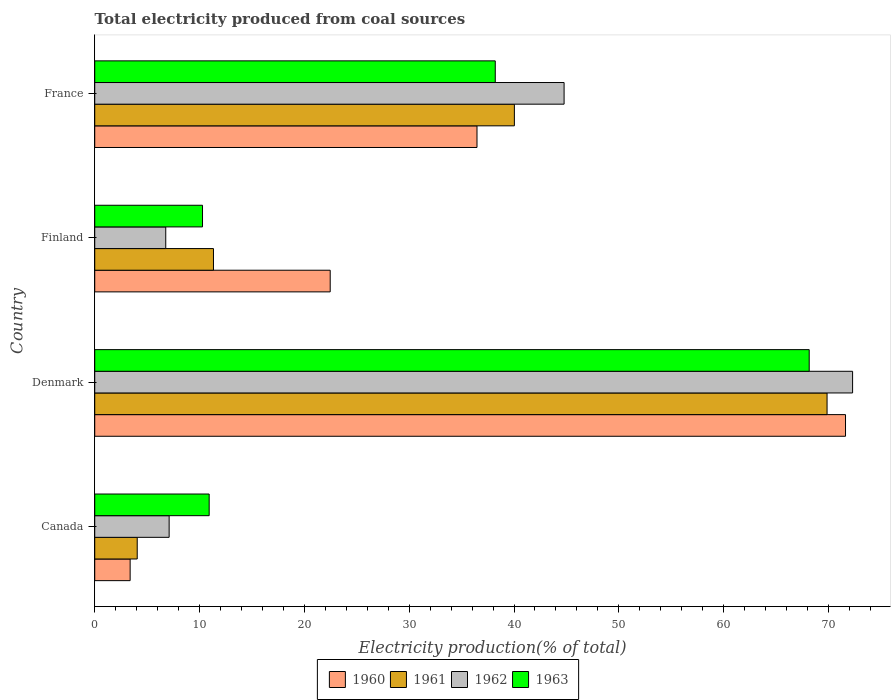How many groups of bars are there?
Provide a short and direct response. 4. Are the number of bars per tick equal to the number of legend labels?
Your answer should be compact. Yes. Are the number of bars on each tick of the Y-axis equal?
Ensure brevity in your answer.  Yes. How many bars are there on the 1st tick from the top?
Provide a short and direct response. 4. What is the total electricity produced in 1963 in Finland?
Your response must be concise. 10.28. Across all countries, what is the maximum total electricity produced in 1963?
Make the answer very short. 68.16. Across all countries, what is the minimum total electricity produced in 1962?
Keep it short and to the point. 6.78. What is the total total electricity produced in 1961 in the graph?
Provide a short and direct response. 125.28. What is the difference between the total electricity produced in 1960 in Denmark and that in France?
Offer a very short reply. 35.16. What is the difference between the total electricity produced in 1962 in Denmark and the total electricity produced in 1963 in Finland?
Offer a very short reply. 62.02. What is the average total electricity produced in 1960 per country?
Provide a short and direct response. 33.48. What is the difference between the total electricity produced in 1962 and total electricity produced in 1960 in Finland?
Your response must be concise. -15.69. In how many countries, is the total electricity produced in 1960 greater than 36 %?
Offer a very short reply. 2. What is the ratio of the total electricity produced in 1963 in Denmark to that in France?
Provide a succinct answer. 1.78. Is the total electricity produced in 1962 in Canada less than that in Denmark?
Your answer should be compact. Yes. Is the difference between the total electricity produced in 1962 in Finland and France greater than the difference between the total electricity produced in 1960 in Finland and France?
Make the answer very short. No. What is the difference between the highest and the second highest total electricity produced in 1961?
Offer a terse response. 29.83. What is the difference between the highest and the lowest total electricity produced in 1961?
Provide a succinct answer. 65.81. Is the sum of the total electricity produced in 1960 in Denmark and France greater than the maximum total electricity produced in 1962 across all countries?
Provide a short and direct response. Yes. Is it the case that in every country, the sum of the total electricity produced in 1960 and total electricity produced in 1962 is greater than the sum of total electricity produced in 1963 and total electricity produced in 1961?
Your answer should be very brief. No. What does the 1st bar from the top in France represents?
Keep it short and to the point. 1963. What does the 3rd bar from the bottom in Finland represents?
Your response must be concise. 1962. Is it the case that in every country, the sum of the total electricity produced in 1961 and total electricity produced in 1960 is greater than the total electricity produced in 1962?
Provide a short and direct response. Yes. Are all the bars in the graph horizontal?
Make the answer very short. Yes. What is the difference between two consecutive major ticks on the X-axis?
Your answer should be compact. 10. Are the values on the major ticks of X-axis written in scientific E-notation?
Keep it short and to the point. No. Does the graph contain any zero values?
Your answer should be compact. No. How many legend labels are there?
Keep it short and to the point. 4. What is the title of the graph?
Offer a terse response. Total electricity produced from coal sources. What is the label or title of the X-axis?
Make the answer very short. Electricity production(% of total). What is the Electricity production(% of total) of 1960 in Canada?
Your response must be concise. 3.38. What is the Electricity production(% of total) in 1961 in Canada?
Provide a succinct answer. 4.05. What is the Electricity production(% of total) of 1962 in Canada?
Offer a very short reply. 7.1. What is the Electricity production(% of total) of 1963 in Canada?
Ensure brevity in your answer.  10.92. What is the Electricity production(% of total) of 1960 in Denmark?
Offer a very short reply. 71.62. What is the Electricity production(% of total) of 1961 in Denmark?
Provide a succinct answer. 69.86. What is the Electricity production(% of total) in 1962 in Denmark?
Your answer should be very brief. 72.3. What is the Electricity production(% of total) of 1963 in Denmark?
Your answer should be compact. 68.16. What is the Electricity production(% of total) of 1960 in Finland?
Your response must be concise. 22.46. What is the Electricity production(% of total) of 1961 in Finland?
Ensure brevity in your answer.  11.33. What is the Electricity production(% of total) in 1962 in Finland?
Ensure brevity in your answer.  6.78. What is the Electricity production(% of total) of 1963 in Finland?
Provide a short and direct response. 10.28. What is the Electricity production(% of total) of 1960 in France?
Provide a succinct answer. 36.47. What is the Electricity production(% of total) in 1961 in France?
Your response must be concise. 40.03. What is the Electricity production(% of total) in 1962 in France?
Ensure brevity in your answer.  44.78. What is the Electricity production(% of total) in 1963 in France?
Give a very brief answer. 38.21. Across all countries, what is the maximum Electricity production(% of total) in 1960?
Your answer should be compact. 71.62. Across all countries, what is the maximum Electricity production(% of total) in 1961?
Keep it short and to the point. 69.86. Across all countries, what is the maximum Electricity production(% of total) of 1962?
Keep it short and to the point. 72.3. Across all countries, what is the maximum Electricity production(% of total) in 1963?
Provide a short and direct response. 68.16. Across all countries, what is the minimum Electricity production(% of total) in 1960?
Your answer should be very brief. 3.38. Across all countries, what is the minimum Electricity production(% of total) in 1961?
Offer a terse response. 4.05. Across all countries, what is the minimum Electricity production(% of total) of 1962?
Give a very brief answer. 6.78. Across all countries, what is the minimum Electricity production(% of total) of 1963?
Make the answer very short. 10.28. What is the total Electricity production(% of total) in 1960 in the graph?
Make the answer very short. 133.93. What is the total Electricity production(% of total) in 1961 in the graph?
Offer a very short reply. 125.28. What is the total Electricity production(% of total) of 1962 in the graph?
Make the answer very short. 130.95. What is the total Electricity production(% of total) of 1963 in the graph?
Give a very brief answer. 127.57. What is the difference between the Electricity production(% of total) in 1960 in Canada and that in Denmark?
Your response must be concise. -68.25. What is the difference between the Electricity production(% of total) of 1961 in Canada and that in Denmark?
Provide a succinct answer. -65.81. What is the difference between the Electricity production(% of total) of 1962 in Canada and that in Denmark?
Ensure brevity in your answer.  -65.2. What is the difference between the Electricity production(% of total) in 1963 in Canada and that in Denmark?
Ensure brevity in your answer.  -57.24. What is the difference between the Electricity production(% of total) of 1960 in Canada and that in Finland?
Offer a terse response. -19.09. What is the difference between the Electricity production(% of total) in 1961 in Canada and that in Finland?
Provide a succinct answer. -7.27. What is the difference between the Electricity production(% of total) in 1962 in Canada and that in Finland?
Offer a very short reply. 0.32. What is the difference between the Electricity production(% of total) of 1963 in Canada and that in Finland?
Make the answer very short. 0.63. What is the difference between the Electricity production(% of total) of 1960 in Canada and that in France?
Ensure brevity in your answer.  -33.09. What is the difference between the Electricity production(% of total) in 1961 in Canada and that in France?
Provide a short and direct response. -35.98. What is the difference between the Electricity production(% of total) in 1962 in Canada and that in France?
Make the answer very short. -37.68. What is the difference between the Electricity production(% of total) in 1963 in Canada and that in France?
Your answer should be very brief. -27.29. What is the difference between the Electricity production(% of total) of 1960 in Denmark and that in Finland?
Your response must be concise. 49.16. What is the difference between the Electricity production(% of total) of 1961 in Denmark and that in Finland?
Your answer should be very brief. 58.54. What is the difference between the Electricity production(% of total) in 1962 in Denmark and that in Finland?
Keep it short and to the point. 65.53. What is the difference between the Electricity production(% of total) in 1963 in Denmark and that in Finland?
Provide a short and direct response. 57.88. What is the difference between the Electricity production(% of total) of 1960 in Denmark and that in France?
Give a very brief answer. 35.16. What is the difference between the Electricity production(% of total) of 1961 in Denmark and that in France?
Make the answer very short. 29.83. What is the difference between the Electricity production(% of total) of 1962 in Denmark and that in France?
Ensure brevity in your answer.  27.52. What is the difference between the Electricity production(% of total) in 1963 in Denmark and that in France?
Your response must be concise. 29.95. What is the difference between the Electricity production(% of total) of 1960 in Finland and that in France?
Give a very brief answer. -14.01. What is the difference between the Electricity production(% of total) in 1961 in Finland and that in France?
Your answer should be compact. -28.71. What is the difference between the Electricity production(% of total) of 1962 in Finland and that in France?
Your answer should be compact. -38. What is the difference between the Electricity production(% of total) of 1963 in Finland and that in France?
Keep it short and to the point. -27.93. What is the difference between the Electricity production(% of total) of 1960 in Canada and the Electricity production(% of total) of 1961 in Denmark?
Make the answer very short. -66.49. What is the difference between the Electricity production(% of total) of 1960 in Canada and the Electricity production(% of total) of 1962 in Denmark?
Keep it short and to the point. -68.92. What is the difference between the Electricity production(% of total) of 1960 in Canada and the Electricity production(% of total) of 1963 in Denmark?
Your answer should be compact. -64.78. What is the difference between the Electricity production(% of total) in 1961 in Canada and the Electricity production(% of total) in 1962 in Denmark?
Ensure brevity in your answer.  -68.25. What is the difference between the Electricity production(% of total) in 1961 in Canada and the Electricity production(% of total) in 1963 in Denmark?
Your response must be concise. -64.11. What is the difference between the Electricity production(% of total) in 1962 in Canada and the Electricity production(% of total) in 1963 in Denmark?
Your answer should be very brief. -61.06. What is the difference between the Electricity production(% of total) in 1960 in Canada and the Electricity production(% of total) in 1961 in Finland?
Offer a terse response. -7.95. What is the difference between the Electricity production(% of total) of 1960 in Canada and the Electricity production(% of total) of 1962 in Finland?
Your answer should be very brief. -3.4. What is the difference between the Electricity production(% of total) in 1960 in Canada and the Electricity production(% of total) in 1963 in Finland?
Offer a very short reply. -6.91. What is the difference between the Electricity production(% of total) of 1961 in Canada and the Electricity production(% of total) of 1962 in Finland?
Offer a terse response. -2.72. What is the difference between the Electricity production(% of total) in 1961 in Canada and the Electricity production(% of total) in 1963 in Finland?
Offer a terse response. -6.23. What is the difference between the Electricity production(% of total) of 1962 in Canada and the Electricity production(% of total) of 1963 in Finland?
Make the answer very short. -3.18. What is the difference between the Electricity production(% of total) in 1960 in Canada and the Electricity production(% of total) in 1961 in France?
Provide a short and direct response. -36.66. What is the difference between the Electricity production(% of total) in 1960 in Canada and the Electricity production(% of total) in 1962 in France?
Give a very brief answer. -41.4. What is the difference between the Electricity production(% of total) of 1960 in Canada and the Electricity production(% of total) of 1963 in France?
Your response must be concise. -34.83. What is the difference between the Electricity production(% of total) of 1961 in Canada and the Electricity production(% of total) of 1962 in France?
Make the answer very short. -40.72. What is the difference between the Electricity production(% of total) of 1961 in Canada and the Electricity production(% of total) of 1963 in France?
Offer a terse response. -34.16. What is the difference between the Electricity production(% of total) of 1962 in Canada and the Electricity production(% of total) of 1963 in France?
Offer a very short reply. -31.11. What is the difference between the Electricity production(% of total) in 1960 in Denmark and the Electricity production(% of total) in 1961 in Finland?
Your response must be concise. 60.3. What is the difference between the Electricity production(% of total) of 1960 in Denmark and the Electricity production(% of total) of 1962 in Finland?
Your response must be concise. 64.85. What is the difference between the Electricity production(% of total) of 1960 in Denmark and the Electricity production(% of total) of 1963 in Finland?
Ensure brevity in your answer.  61.34. What is the difference between the Electricity production(% of total) of 1961 in Denmark and the Electricity production(% of total) of 1962 in Finland?
Offer a terse response. 63.09. What is the difference between the Electricity production(% of total) in 1961 in Denmark and the Electricity production(% of total) in 1963 in Finland?
Give a very brief answer. 59.58. What is the difference between the Electricity production(% of total) of 1962 in Denmark and the Electricity production(% of total) of 1963 in Finland?
Give a very brief answer. 62.02. What is the difference between the Electricity production(% of total) in 1960 in Denmark and the Electricity production(% of total) in 1961 in France?
Your answer should be very brief. 31.59. What is the difference between the Electricity production(% of total) in 1960 in Denmark and the Electricity production(% of total) in 1962 in France?
Ensure brevity in your answer.  26.85. What is the difference between the Electricity production(% of total) in 1960 in Denmark and the Electricity production(% of total) in 1963 in France?
Your answer should be compact. 33.41. What is the difference between the Electricity production(% of total) in 1961 in Denmark and the Electricity production(% of total) in 1962 in France?
Provide a succinct answer. 25.09. What is the difference between the Electricity production(% of total) in 1961 in Denmark and the Electricity production(% of total) in 1963 in France?
Offer a very short reply. 31.65. What is the difference between the Electricity production(% of total) of 1962 in Denmark and the Electricity production(% of total) of 1963 in France?
Your response must be concise. 34.09. What is the difference between the Electricity production(% of total) of 1960 in Finland and the Electricity production(% of total) of 1961 in France?
Provide a succinct answer. -17.57. What is the difference between the Electricity production(% of total) in 1960 in Finland and the Electricity production(% of total) in 1962 in France?
Provide a succinct answer. -22.31. What is the difference between the Electricity production(% of total) in 1960 in Finland and the Electricity production(% of total) in 1963 in France?
Your answer should be compact. -15.75. What is the difference between the Electricity production(% of total) of 1961 in Finland and the Electricity production(% of total) of 1962 in France?
Provide a succinct answer. -33.45. What is the difference between the Electricity production(% of total) of 1961 in Finland and the Electricity production(% of total) of 1963 in France?
Make the answer very short. -26.88. What is the difference between the Electricity production(% of total) in 1962 in Finland and the Electricity production(% of total) in 1963 in France?
Give a very brief answer. -31.44. What is the average Electricity production(% of total) in 1960 per country?
Make the answer very short. 33.48. What is the average Electricity production(% of total) in 1961 per country?
Your answer should be very brief. 31.32. What is the average Electricity production(% of total) in 1962 per country?
Provide a short and direct response. 32.74. What is the average Electricity production(% of total) of 1963 per country?
Your answer should be compact. 31.89. What is the difference between the Electricity production(% of total) of 1960 and Electricity production(% of total) of 1961 in Canada?
Ensure brevity in your answer.  -0.68. What is the difference between the Electricity production(% of total) in 1960 and Electricity production(% of total) in 1962 in Canada?
Your answer should be compact. -3.72. What is the difference between the Electricity production(% of total) of 1960 and Electricity production(% of total) of 1963 in Canada?
Ensure brevity in your answer.  -7.54. What is the difference between the Electricity production(% of total) of 1961 and Electricity production(% of total) of 1962 in Canada?
Your answer should be compact. -3.04. What is the difference between the Electricity production(% of total) of 1961 and Electricity production(% of total) of 1963 in Canada?
Your answer should be very brief. -6.86. What is the difference between the Electricity production(% of total) in 1962 and Electricity production(% of total) in 1963 in Canada?
Provide a short and direct response. -3.82. What is the difference between the Electricity production(% of total) of 1960 and Electricity production(% of total) of 1961 in Denmark?
Offer a terse response. 1.76. What is the difference between the Electricity production(% of total) of 1960 and Electricity production(% of total) of 1962 in Denmark?
Your answer should be very brief. -0.68. What is the difference between the Electricity production(% of total) of 1960 and Electricity production(% of total) of 1963 in Denmark?
Make the answer very short. 3.46. What is the difference between the Electricity production(% of total) in 1961 and Electricity production(% of total) in 1962 in Denmark?
Your answer should be compact. -2.44. What is the difference between the Electricity production(% of total) in 1961 and Electricity production(% of total) in 1963 in Denmark?
Make the answer very short. 1.7. What is the difference between the Electricity production(% of total) in 1962 and Electricity production(% of total) in 1963 in Denmark?
Keep it short and to the point. 4.14. What is the difference between the Electricity production(% of total) in 1960 and Electricity production(% of total) in 1961 in Finland?
Give a very brief answer. 11.14. What is the difference between the Electricity production(% of total) in 1960 and Electricity production(% of total) in 1962 in Finland?
Provide a succinct answer. 15.69. What is the difference between the Electricity production(% of total) in 1960 and Electricity production(% of total) in 1963 in Finland?
Your response must be concise. 12.18. What is the difference between the Electricity production(% of total) in 1961 and Electricity production(% of total) in 1962 in Finland?
Make the answer very short. 4.55. What is the difference between the Electricity production(% of total) in 1961 and Electricity production(% of total) in 1963 in Finland?
Offer a terse response. 1.04. What is the difference between the Electricity production(% of total) in 1962 and Electricity production(% of total) in 1963 in Finland?
Provide a succinct answer. -3.51. What is the difference between the Electricity production(% of total) of 1960 and Electricity production(% of total) of 1961 in France?
Provide a succinct answer. -3.57. What is the difference between the Electricity production(% of total) of 1960 and Electricity production(% of total) of 1962 in France?
Offer a very short reply. -8.31. What is the difference between the Electricity production(% of total) in 1960 and Electricity production(% of total) in 1963 in France?
Your response must be concise. -1.74. What is the difference between the Electricity production(% of total) in 1961 and Electricity production(% of total) in 1962 in France?
Offer a very short reply. -4.74. What is the difference between the Electricity production(% of total) of 1961 and Electricity production(% of total) of 1963 in France?
Provide a short and direct response. 1.82. What is the difference between the Electricity production(% of total) of 1962 and Electricity production(% of total) of 1963 in France?
Offer a terse response. 6.57. What is the ratio of the Electricity production(% of total) in 1960 in Canada to that in Denmark?
Your answer should be very brief. 0.05. What is the ratio of the Electricity production(% of total) of 1961 in Canada to that in Denmark?
Offer a very short reply. 0.06. What is the ratio of the Electricity production(% of total) of 1962 in Canada to that in Denmark?
Offer a very short reply. 0.1. What is the ratio of the Electricity production(% of total) in 1963 in Canada to that in Denmark?
Make the answer very short. 0.16. What is the ratio of the Electricity production(% of total) in 1960 in Canada to that in Finland?
Give a very brief answer. 0.15. What is the ratio of the Electricity production(% of total) of 1961 in Canada to that in Finland?
Provide a short and direct response. 0.36. What is the ratio of the Electricity production(% of total) of 1962 in Canada to that in Finland?
Your answer should be compact. 1.05. What is the ratio of the Electricity production(% of total) of 1963 in Canada to that in Finland?
Provide a succinct answer. 1.06. What is the ratio of the Electricity production(% of total) of 1960 in Canada to that in France?
Ensure brevity in your answer.  0.09. What is the ratio of the Electricity production(% of total) of 1961 in Canada to that in France?
Offer a terse response. 0.1. What is the ratio of the Electricity production(% of total) of 1962 in Canada to that in France?
Your answer should be compact. 0.16. What is the ratio of the Electricity production(% of total) of 1963 in Canada to that in France?
Your answer should be very brief. 0.29. What is the ratio of the Electricity production(% of total) in 1960 in Denmark to that in Finland?
Make the answer very short. 3.19. What is the ratio of the Electricity production(% of total) in 1961 in Denmark to that in Finland?
Ensure brevity in your answer.  6.17. What is the ratio of the Electricity production(% of total) of 1962 in Denmark to that in Finland?
Your answer should be very brief. 10.67. What is the ratio of the Electricity production(% of total) in 1963 in Denmark to that in Finland?
Offer a very short reply. 6.63. What is the ratio of the Electricity production(% of total) of 1960 in Denmark to that in France?
Offer a very short reply. 1.96. What is the ratio of the Electricity production(% of total) of 1961 in Denmark to that in France?
Offer a very short reply. 1.75. What is the ratio of the Electricity production(% of total) in 1962 in Denmark to that in France?
Your answer should be compact. 1.61. What is the ratio of the Electricity production(% of total) of 1963 in Denmark to that in France?
Provide a short and direct response. 1.78. What is the ratio of the Electricity production(% of total) in 1960 in Finland to that in France?
Offer a terse response. 0.62. What is the ratio of the Electricity production(% of total) in 1961 in Finland to that in France?
Your answer should be compact. 0.28. What is the ratio of the Electricity production(% of total) of 1962 in Finland to that in France?
Provide a succinct answer. 0.15. What is the ratio of the Electricity production(% of total) in 1963 in Finland to that in France?
Provide a short and direct response. 0.27. What is the difference between the highest and the second highest Electricity production(% of total) of 1960?
Your answer should be compact. 35.16. What is the difference between the highest and the second highest Electricity production(% of total) of 1961?
Offer a very short reply. 29.83. What is the difference between the highest and the second highest Electricity production(% of total) of 1962?
Give a very brief answer. 27.52. What is the difference between the highest and the second highest Electricity production(% of total) in 1963?
Your answer should be compact. 29.95. What is the difference between the highest and the lowest Electricity production(% of total) in 1960?
Provide a succinct answer. 68.25. What is the difference between the highest and the lowest Electricity production(% of total) of 1961?
Provide a succinct answer. 65.81. What is the difference between the highest and the lowest Electricity production(% of total) in 1962?
Make the answer very short. 65.53. What is the difference between the highest and the lowest Electricity production(% of total) in 1963?
Keep it short and to the point. 57.88. 